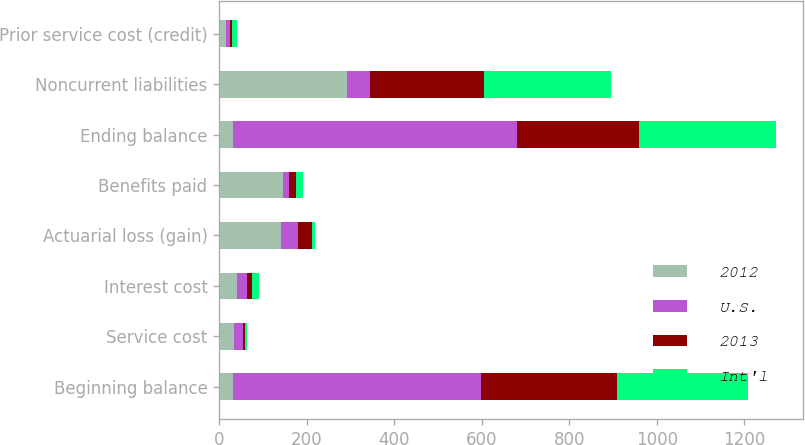<chart> <loc_0><loc_0><loc_500><loc_500><stacked_bar_chart><ecel><fcel>Beginning balance<fcel>Service cost<fcel>Interest cost<fcel>Actuarial loss (gain)<fcel>Benefits paid<fcel>Ending balance<fcel>Noncurrent liabilities<fcel>Prior service cost (credit)<nl><fcel>2012<fcel>32<fcel>33<fcel>40<fcel>140<fcel>146<fcel>32<fcel>292<fcel>15<nl><fcel>U.S.<fcel>565<fcel>22<fcel>24<fcel>40<fcel>13<fcel>649<fcel>52<fcel>9<nl><fcel>2013<fcel>311<fcel>4<fcel>12<fcel>31<fcel>17<fcel>279<fcel>260<fcel>5<nl><fcel>Int'l<fcel>301<fcel>4<fcel>14<fcel>8<fcel>16<fcel>311<fcel>292<fcel>11<nl></chart> 